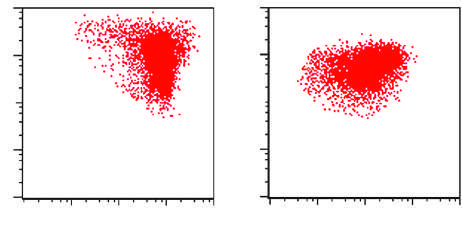does show flow cytometry result for the all shown in the figure?
Answer the question using a single word or phrase. Yes 